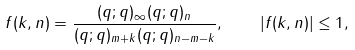Convert formula to latex. <formula><loc_0><loc_0><loc_500><loc_500>f ( k , n ) = \frac { ( q ; q ) _ { \infty } ( q ; q ) _ { n } } { ( q ; q ) _ { m + k } ( q ; q ) _ { n - m - k } } , \quad | f ( k , n ) | \leq 1 ,</formula> 